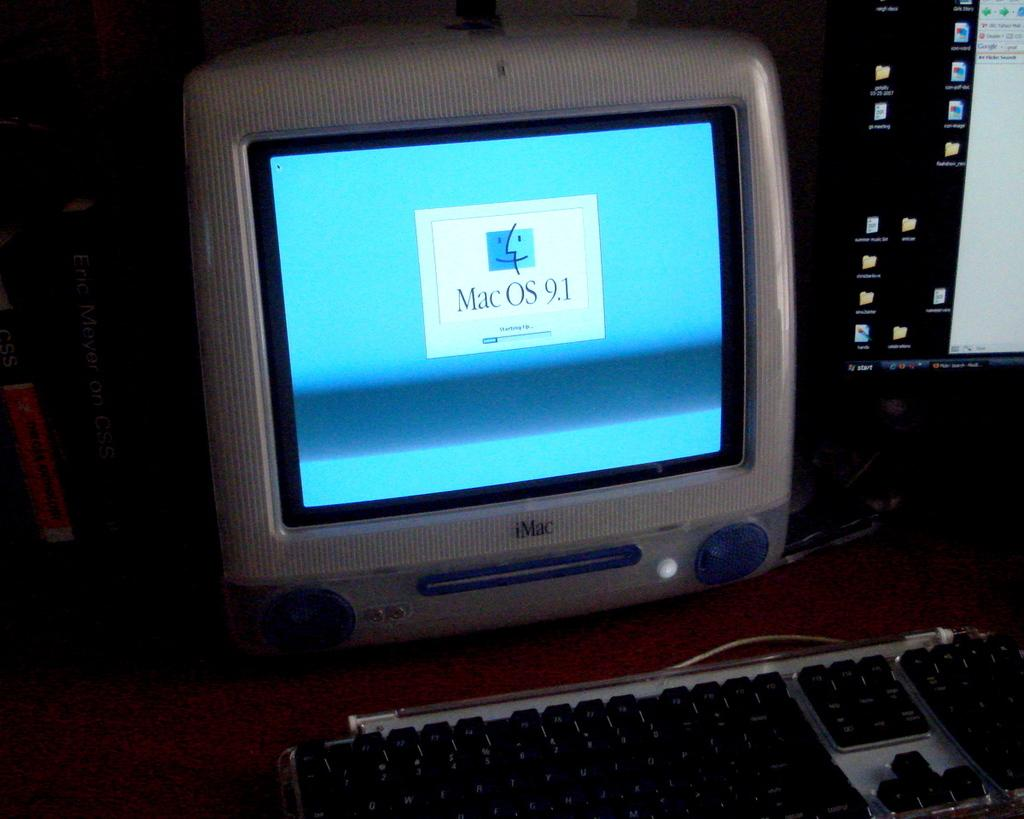<image>
Write a terse but informative summary of the picture. An old iMac running MacOS 9.1 next to a monitor running Windows. 